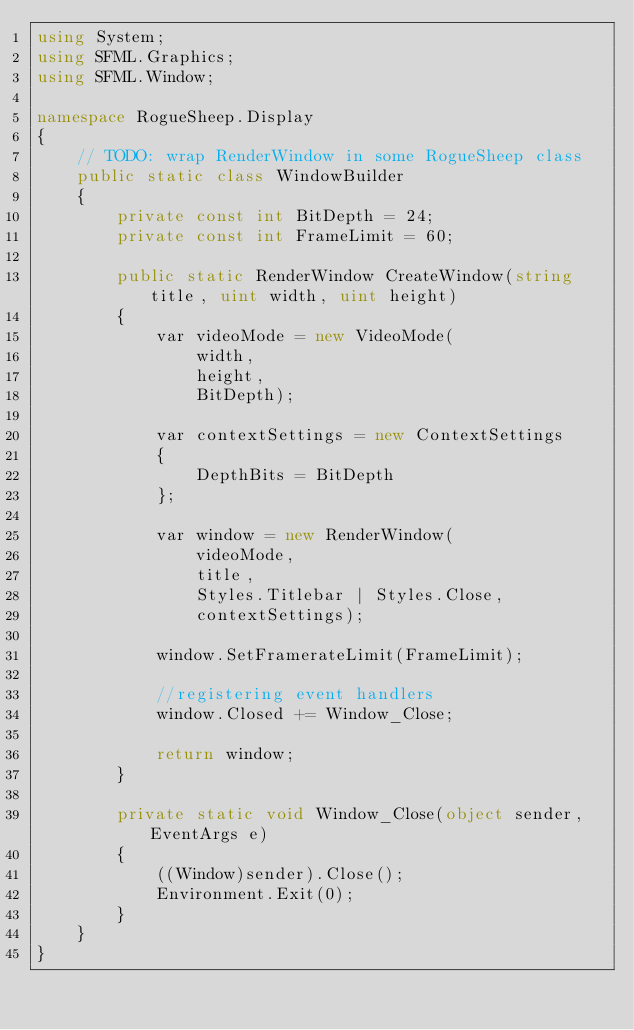<code> <loc_0><loc_0><loc_500><loc_500><_C#_>using System;
using SFML.Graphics;
using SFML.Window;

namespace RogueSheep.Display
{
    // TODO: wrap RenderWindow in some RogueSheep class
    public static class WindowBuilder
    {
        private const int BitDepth = 24;
        private const int FrameLimit = 60;

        public static RenderWindow CreateWindow(string title, uint width, uint height)
        {
            var videoMode = new VideoMode(
                width,
                height,
                BitDepth);

            var contextSettings = new ContextSettings
            {
                DepthBits = BitDepth
            };

            var window = new RenderWindow(
                videoMode,
                title,
                Styles.Titlebar | Styles.Close,
                contextSettings);

            window.SetFramerateLimit(FrameLimit);

            //registering event handlers
            window.Closed += Window_Close;

            return window;
        }

        private static void Window_Close(object sender, EventArgs e)
        {
            ((Window)sender).Close();
            Environment.Exit(0);
        }
    }
}
</code> 